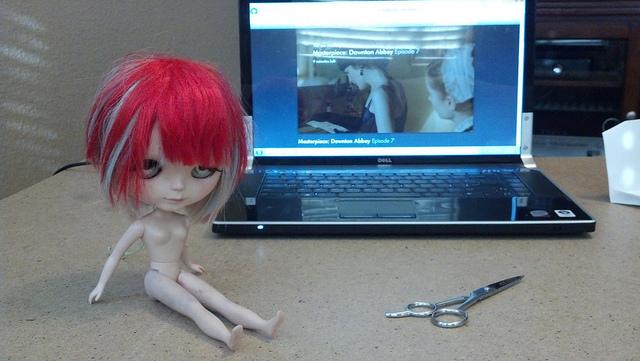What is the doll wearing?
Write a very short answer. Nothing. What color is the doll's hair?
Give a very brief answer. Red. Is the doll's head proportional?
Be succinct. No. 